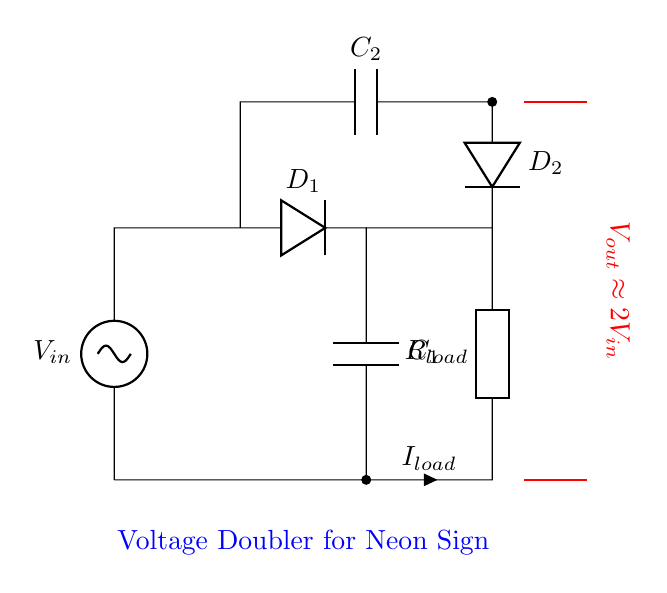What is the input voltage for this circuit? The input voltage, denoted as V_in, is represented by the voltage source in the circuit diagram at the left side, indicating it is the voltage supplied to the circuit.
Answer: V_in What is the role of D_1 in this circuit? D_1 is a diode that conducts current when the input voltage is positive, allowing current to flow to the capacitor C_1 and blocking the reverse current when the input voltage drops.
Answer: Rectification What is the value of the output voltage? The output voltage is approximately twice the input voltage, as indicated in the circuit by the label near the output, which shows that V_out is around 2V_in.
Answer: Approximately 2V_in How many capacitors are present in the circuit? There are two capacitors labeled C_1 and C_2, both included in the circuit for storing charge and contributing to voltage doubling.
Answer: Two What is the purpose of C_2 in this voltage doubler? C_2 stores charge from the circuit during the second half of the cycle, which aids in achieving the voltage doubling effect as it releases its stored charge to the output.
Answer: Charge storage What type of circuit is this? This circuit is a voltage doubler, specifically designed to increase the input voltage for applications like high-voltage neon signs, as indicated by the title in the diagram.
Answer: Voltage doubler What happens to the current when the input voltage increases? When the input voltage increases, the current through the load (I_load) also increases, as per Ohm's law, assuming the load resistor R_load remains constant.
Answer: Increases 